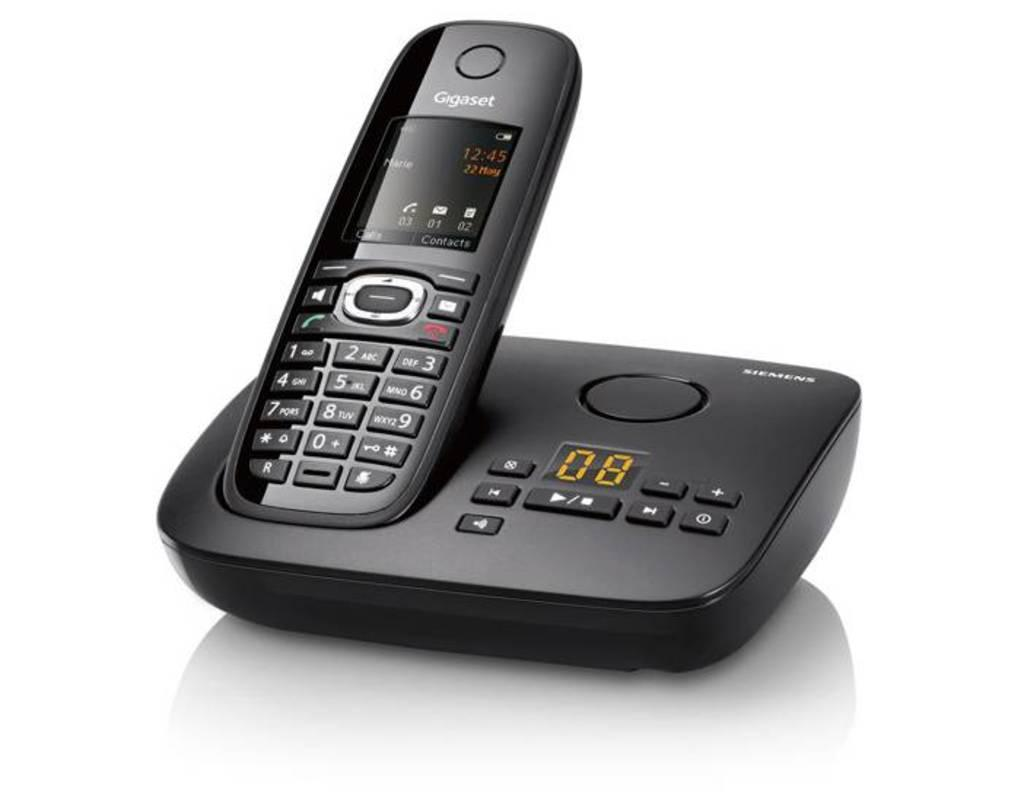Provide a one-sentence caption for the provided image. A Gigaset portable phone is sitting on its base. 